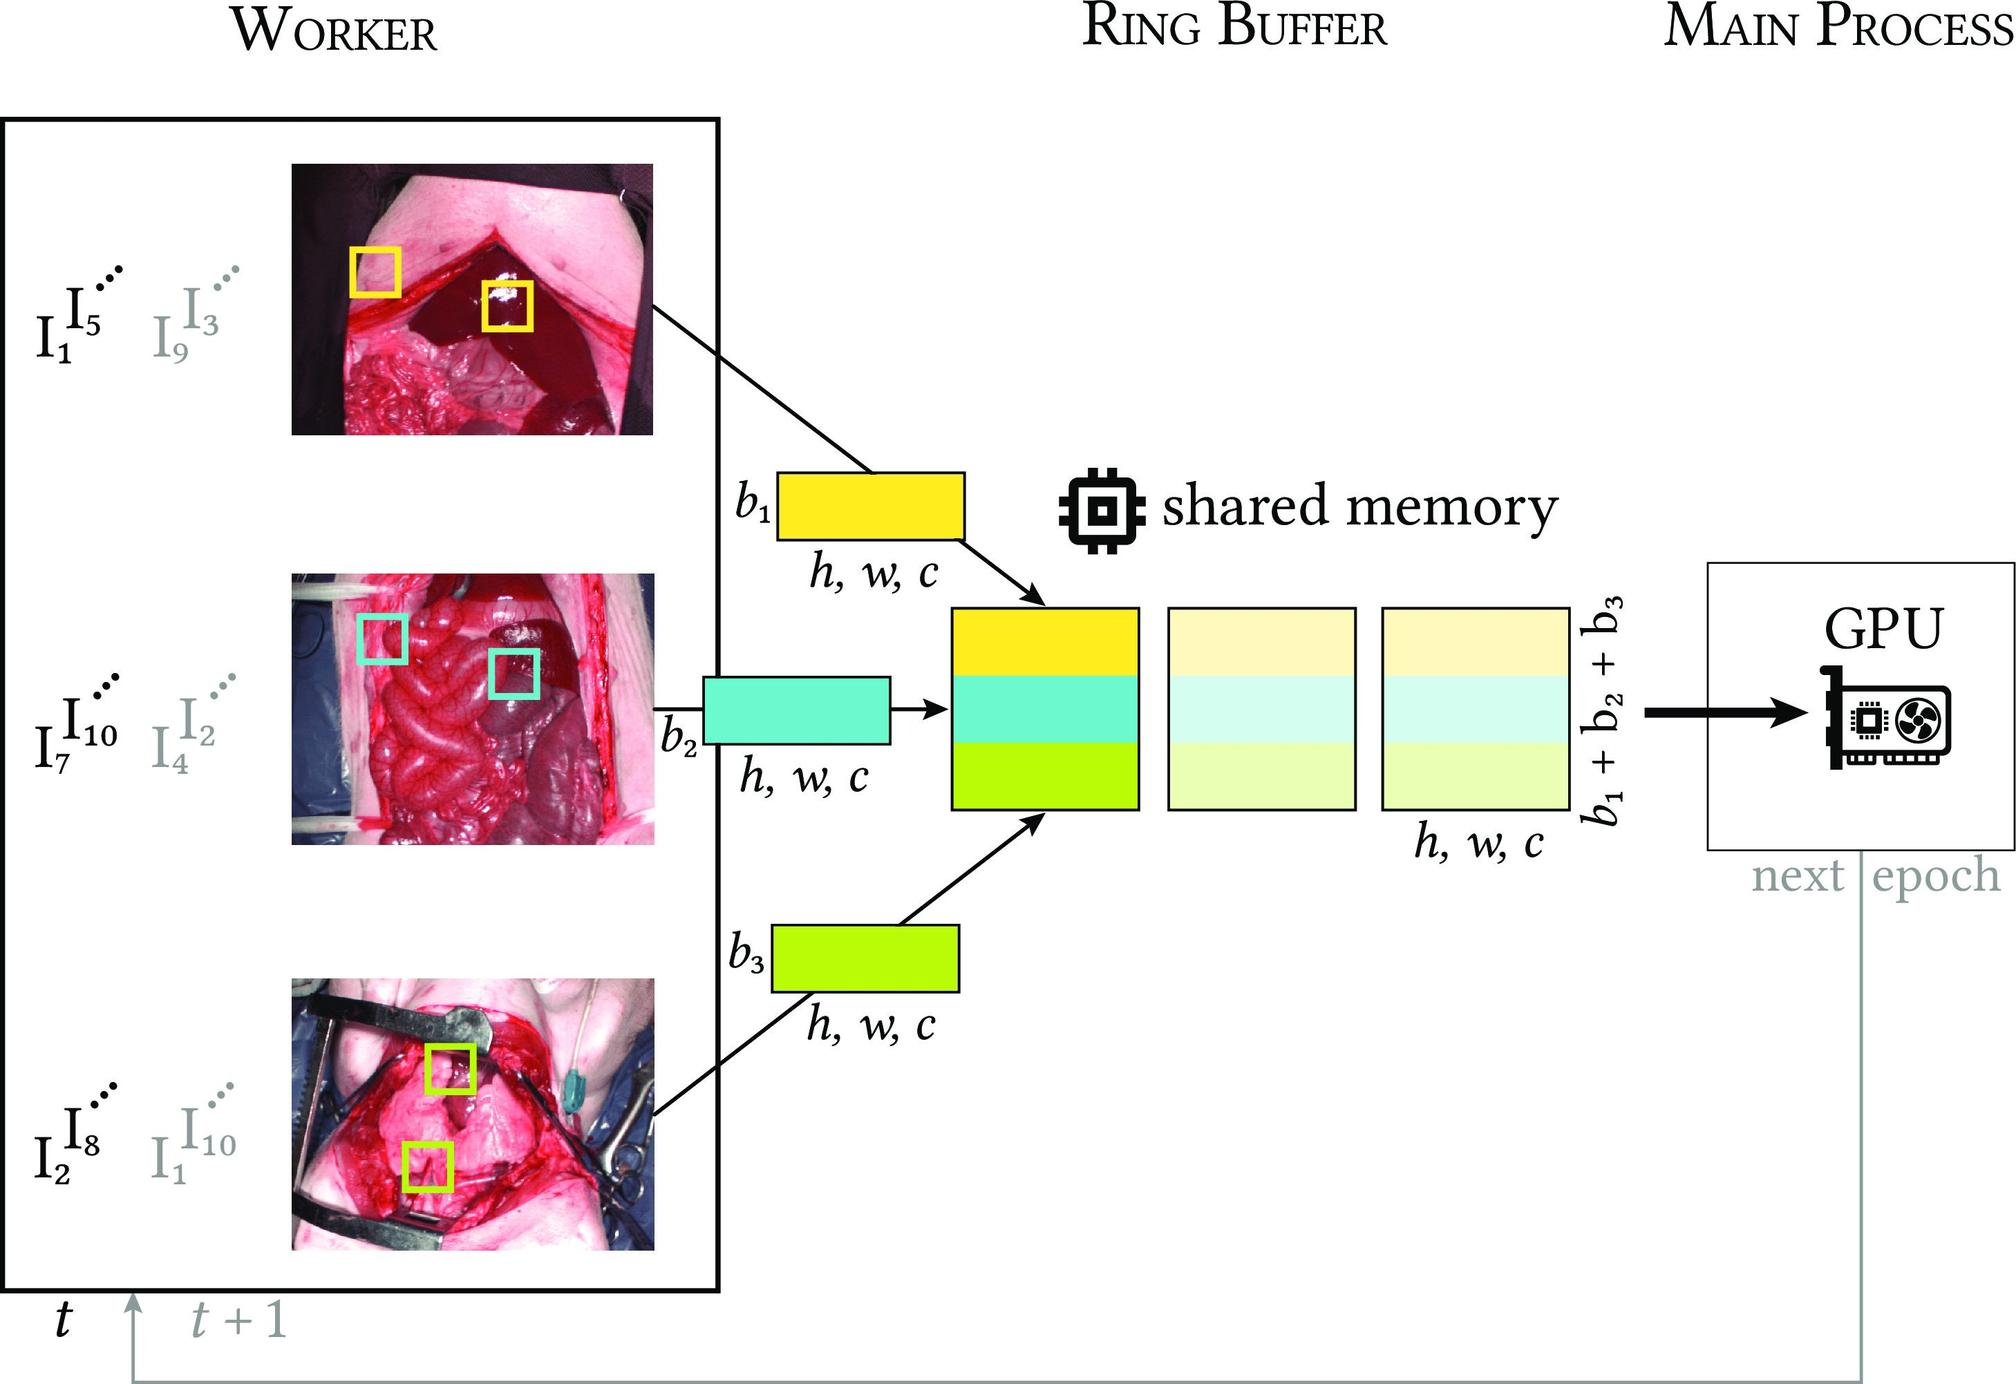What does the 't' at the bottom of the figure represent? A. The threshold level for data processing. B. The type of tasks to be processed. C. The time sequence of images being processed. D. The temperature at which the processing is optimal. The symbol 't' in the diagram, followed by 't + 1', strongly indicates a temporal progression. This generally implies that 't' represents different moments in time. Observing the connections from 't' to the worker and then to a ring buffer suggests that 't' refers to the sequence in time at which images are processed. This temporal sequencing is essential for processing tasks that require continuity and time-based analysis, like video feeds or sequential operations in real-time operations. Therefore, the answer is C - the time sequence of images being processed. 